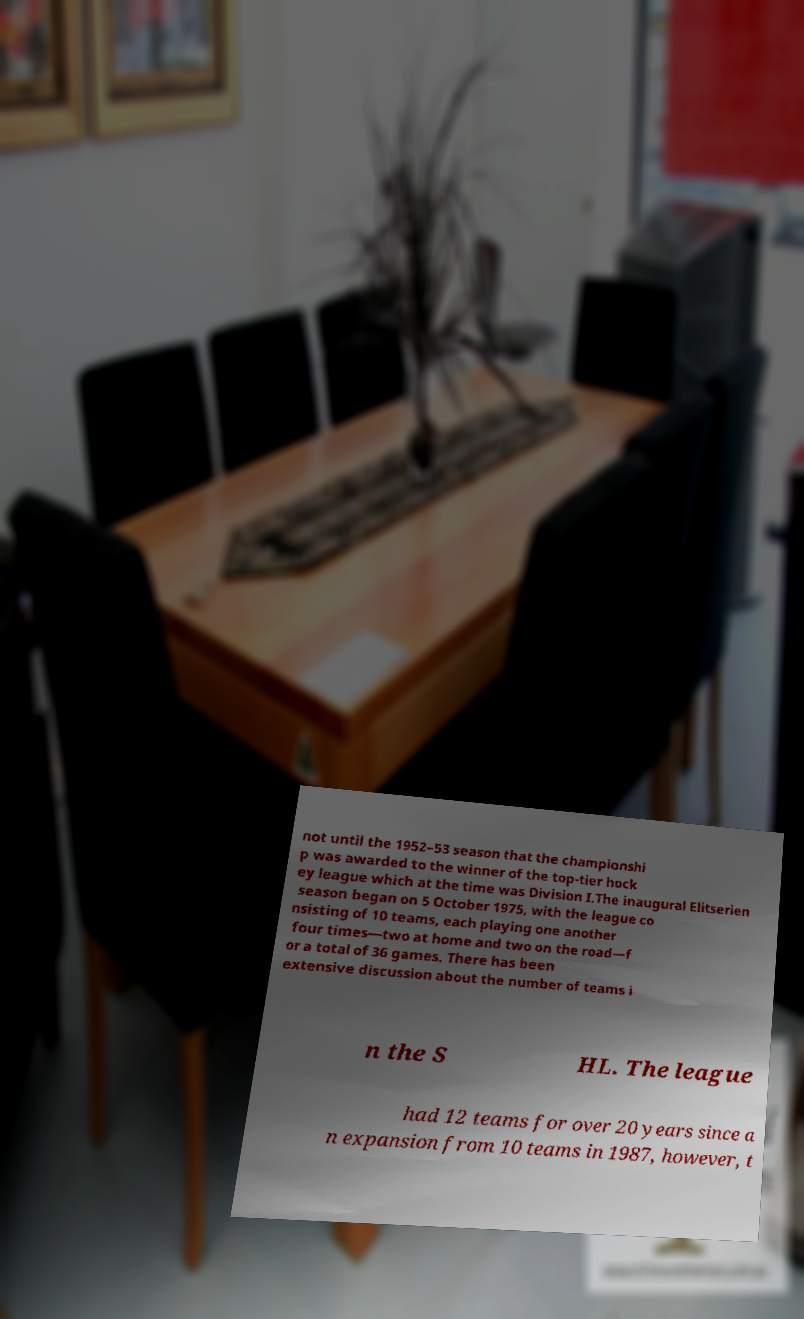What messages or text are displayed in this image? I need them in a readable, typed format. not until the 1952–53 season that the championshi p was awarded to the winner of the top-tier hock ey league which at the time was Division I.The inaugural Elitserien season began on 5 October 1975, with the league co nsisting of 10 teams, each playing one another four times—two at home and two on the road—f or a total of 36 games. There has been extensive discussion about the number of teams i n the S HL. The league had 12 teams for over 20 years since a n expansion from 10 teams in 1987, however, t 